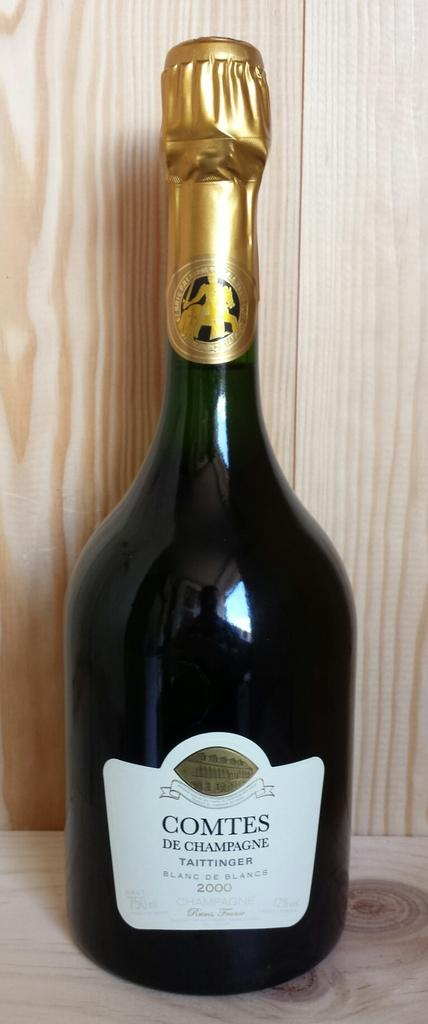Provide a one-sentence caption for the provided image. A bottle of champagne named Comtes De Champagne. 